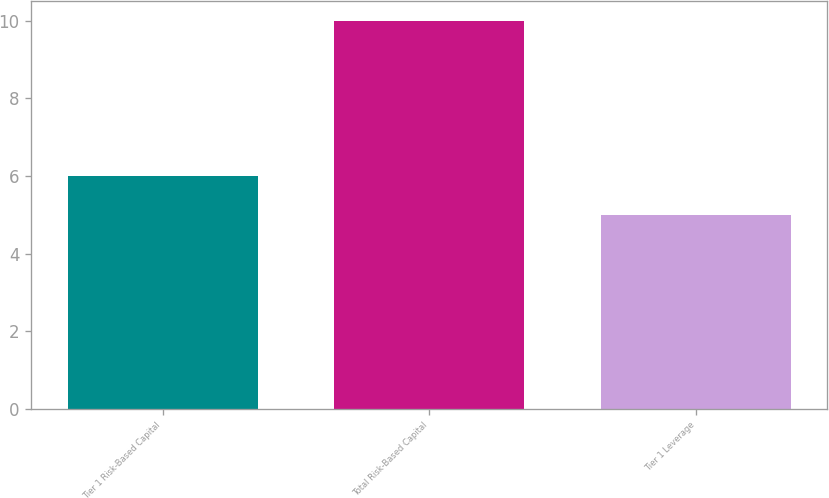Convert chart. <chart><loc_0><loc_0><loc_500><loc_500><bar_chart><fcel>Tier 1 Risk-Based Capital<fcel>Total Risk-Based Capital<fcel>Tier 1 Leverage<nl><fcel>6<fcel>10<fcel>5<nl></chart> 